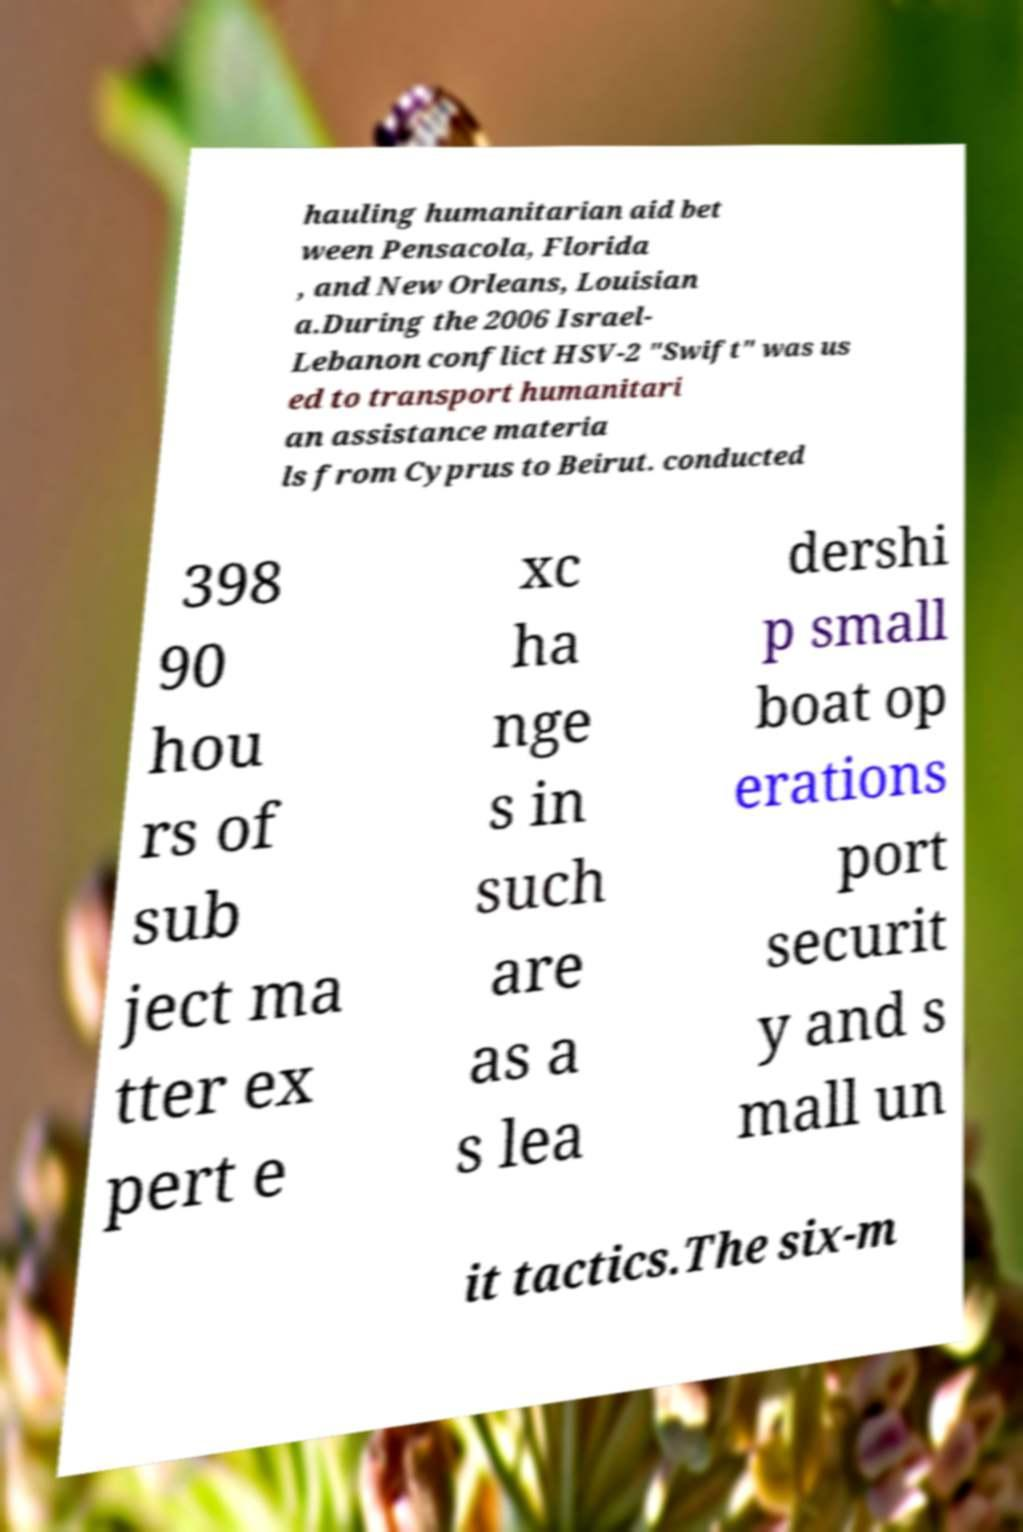Please read and relay the text visible in this image. What does it say? hauling humanitarian aid bet ween Pensacola, Florida , and New Orleans, Louisian a.During the 2006 Israel- Lebanon conflict HSV-2 "Swift" was us ed to transport humanitari an assistance materia ls from Cyprus to Beirut. conducted 398 90 hou rs of sub ject ma tter ex pert e xc ha nge s in such are as a s lea dershi p small boat op erations port securit y and s mall un it tactics.The six-m 